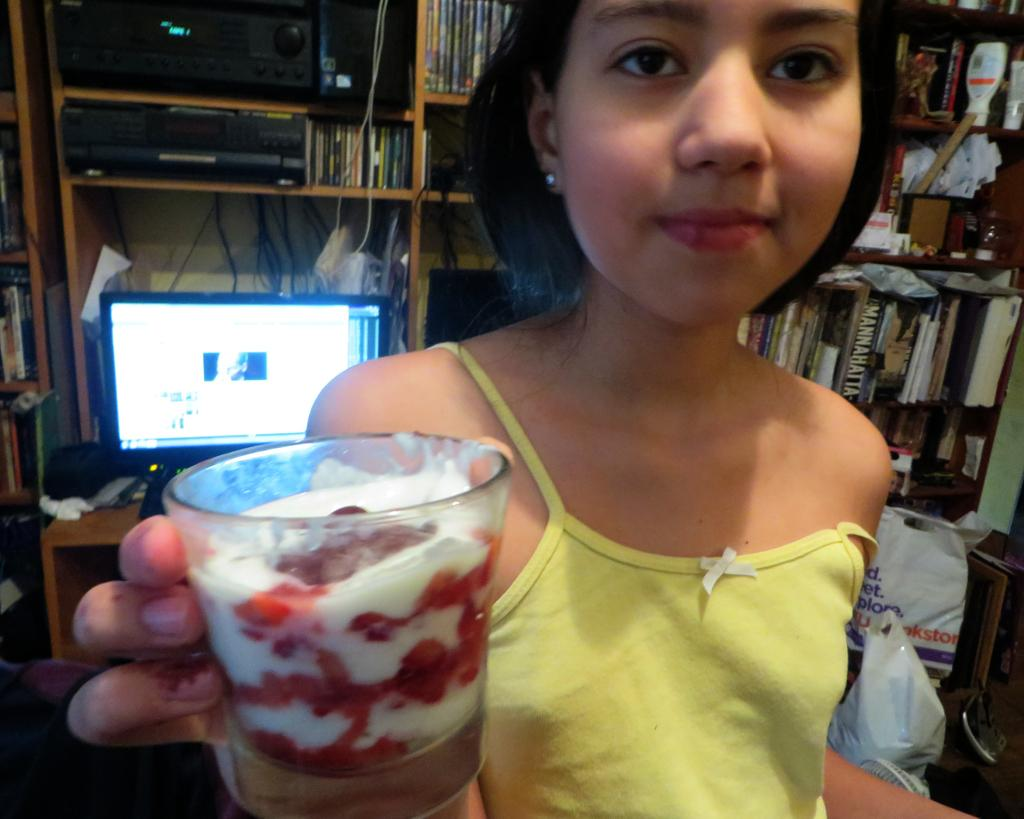Who is the main subject in the image? There is a girl in the image. What is the girl holding in the image? The girl is holding a glass with food. What can be seen in the background of the image? There is a monitor, a table, devices, racks, books, and plastic covers in the background of the image. What type of copper material can be seen in the image? There is no copper material present in the image. Can you tell me how many animals are in the zoo in the image? There is no zoo or animals present in the image. 